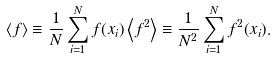Convert formula to latex. <formula><loc_0><loc_0><loc_500><loc_500>\left < f \right > \equiv \frac { 1 } { N } \sum _ { i = 1 } ^ { N } f ( x _ { i } ) \left < f ^ { 2 } \right > \equiv \frac { 1 } { N ^ { 2 } } \sum _ { i = 1 } ^ { N } f ^ { 2 } ( x _ { i } ) .</formula> 